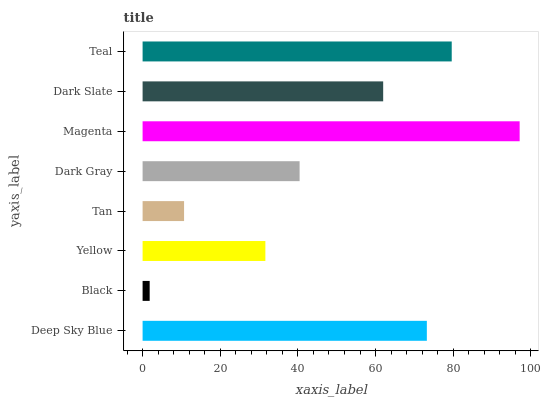Is Black the minimum?
Answer yes or no. Yes. Is Magenta the maximum?
Answer yes or no. Yes. Is Yellow the minimum?
Answer yes or no. No. Is Yellow the maximum?
Answer yes or no. No. Is Yellow greater than Black?
Answer yes or no. Yes. Is Black less than Yellow?
Answer yes or no. Yes. Is Black greater than Yellow?
Answer yes or no. No. Is Yellow less than Black?
Answer yes or no. No. Is Dark Slate the high median?
Answer yes or no. Yes. Is Dark Gray the low median?
Answer yes or no. Yes. Is Yellow the high median?
Answer yes or no. No. Is Deep Sky Blue the low median?
Answer yes or no. No. 